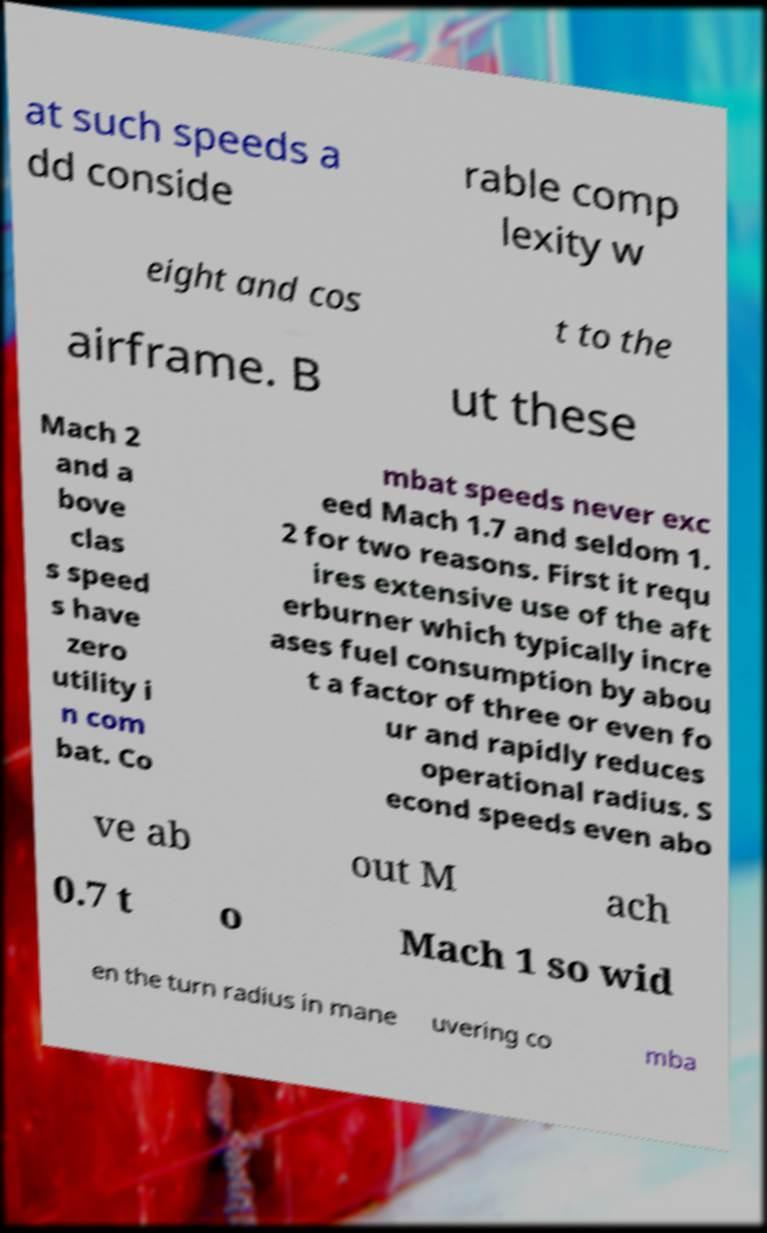For documentation purposes, I need the text within this image transcribed. Could you provide that? at such speeds a dd conside rable comp lexity w eight and cos t to the airframe. B ut these Mach 2 and a bove clas s speed s have zero utility i n com bat. Co mbat speeds never exc eed Mach 1.7 and seldom 1. 2 for two reasons. First it requ ires extensive use of the aft erburner which typically incre ases fuel consumption by abou t a factor of three or even fo ur and rapidly reduces operational radius. S econd speeds even abo ve ab out M ach 0.7 t o Mach 1 so wid en the turn radius in mane uvering co mba 